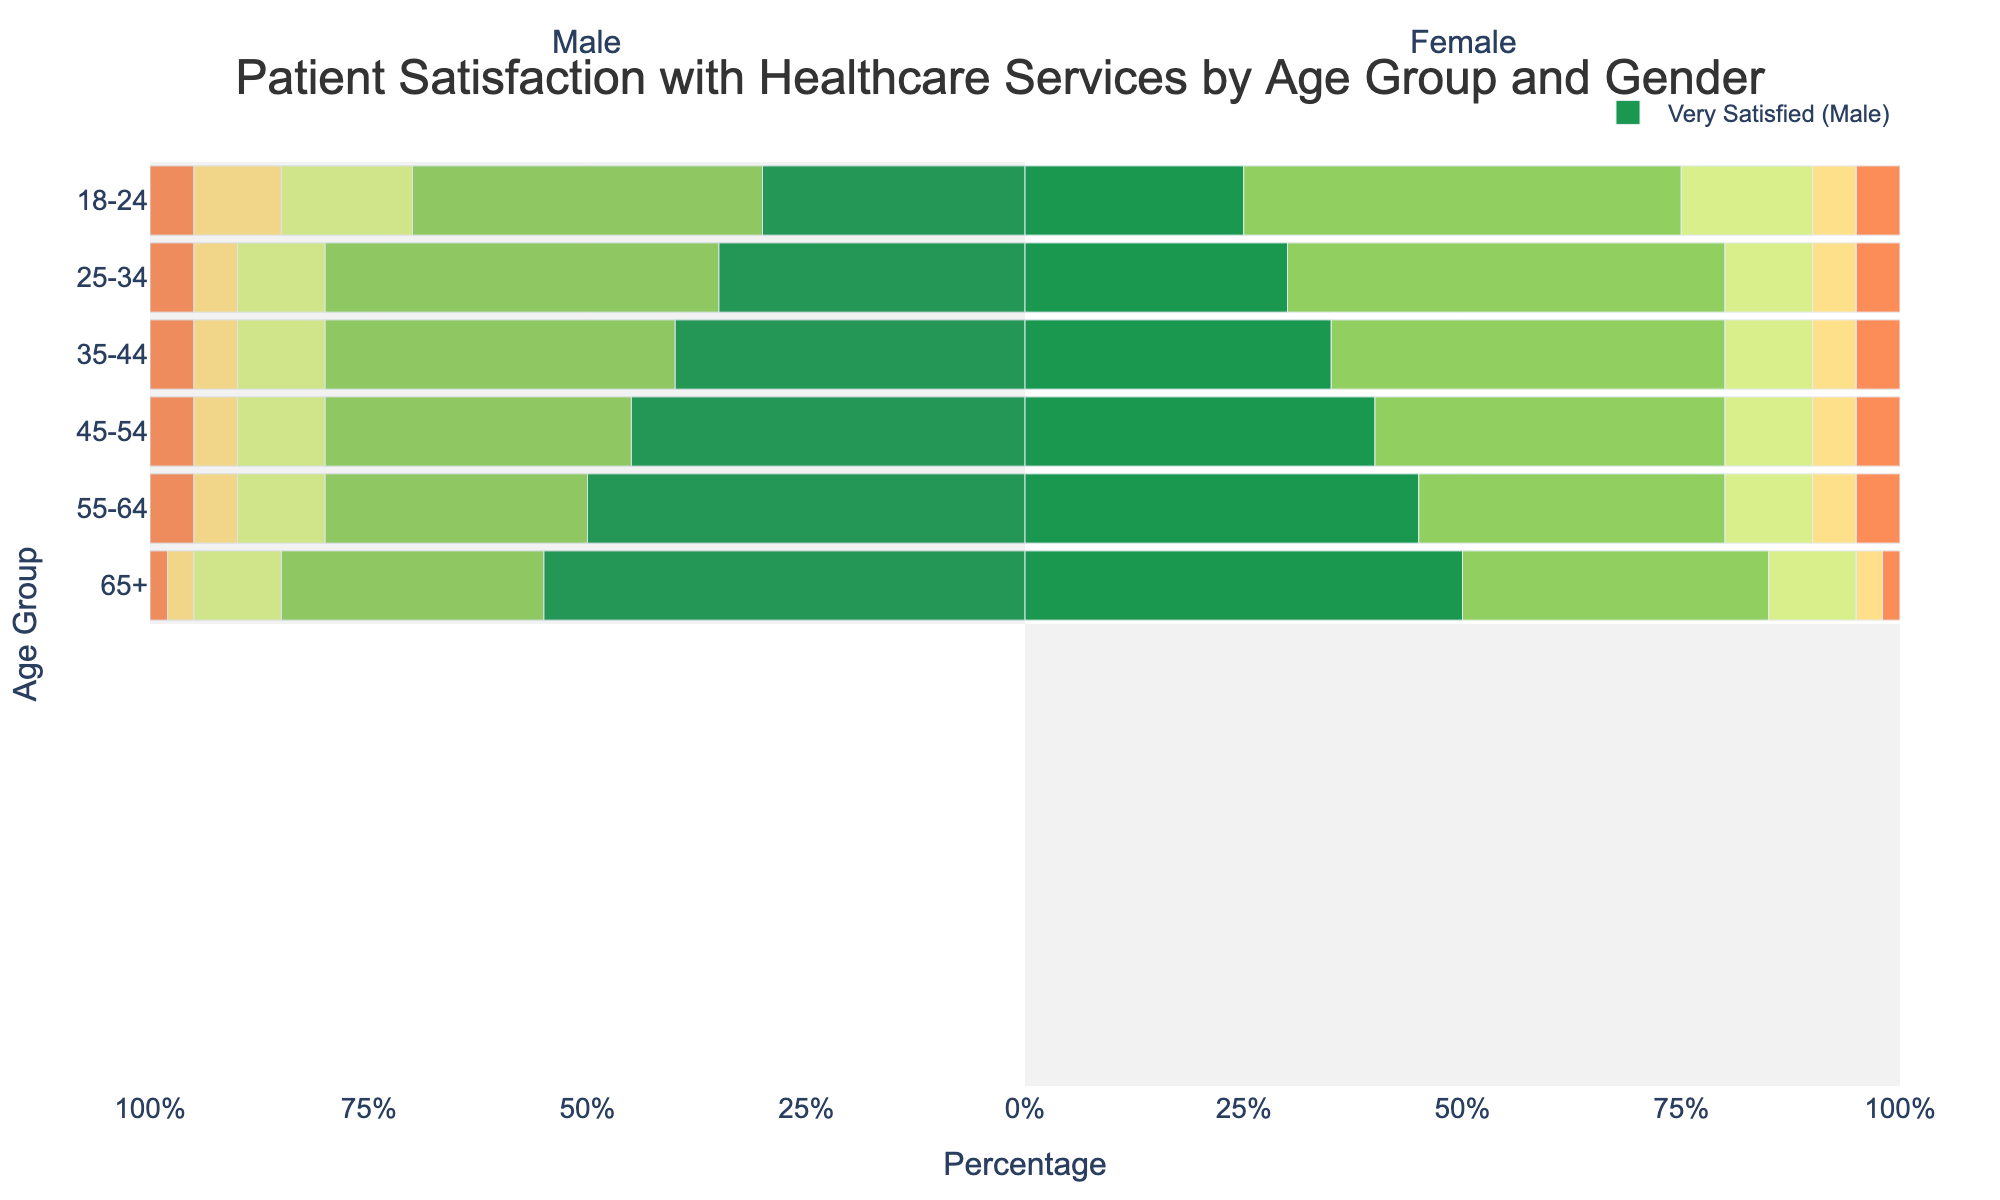What is the total percentage of patients aged 18-24 who are satisfied or very satisfied with healthcare services? To find the total percentage of patients aged 18-24 who are satisfied or very satisfied, sum the percentages of 'Very Satisfied' and 'Satisfied' for both males and females. For males: 30% + 40% = 70%. For females: 25% + 50% = 75%. Since we want the total percentage including both genders, and these are separate groups, we consider both as they are.
Answer: 70% (males), 75% (females) Between males aged 45-54 and females aged 45-54, who has a higher percentage of patients who are very satisfied? Compare the 'Very Satisfied' percentages for males and females in the 45-54 age group. Males: 45%, Females: 40%.
Answer: Males Which age group has the highest percentage of males who are very satisfied? Look for the age group with the highest 'Very Satisfied' percentage among males. 65+ age group has the highest with 55%.
Answer: 65+ For females aged 35-44, what is the combined percentage of those who are neutral or unsatisfied? Add the percentages for 'Neutral' and 'Unsatisfied' for females aged 35-44. Neutral: 10%, Unsatisfied: 5%. Combined: 10% + 5% = 15%.
Answer: 15% What is the difference in the percentage of females who are very unsatisfied between the 55-64 and 65+ age groups? Subtract the percentage of very unsatisfied females in the 65+ age group from that in the 55-64 age group. 55-64: 5%, 65+: 2%. Difference: 5% - 2% = 3%.
Answer: 3% Do males or females have a higher proportion of being very satisfied in the 25-34 age group? Compare the 'Very Satisfied' percentages for males and females in the 25-34 age group. Males: 35%, Females: 30%.
Answer: Males How does the satisfaction level of females aged 55-64 compare to males in the same age group for the categories 'Satisfied' and 'Very Satisfied'? Summing 'Satisfied' and 'Very Satisfied' for each gender, Females: 45% + 35% = 80%, Males: 50% + 30% = 80%. Both have equal satisfaction levels.
Answer: Equal What percentage of females aged 18-24 are either unsatisfied or very unsatisfied? Sum the percentages of 'Unsatisfied' and 'Very Unsatisfied' for females aged 18-24. Unsatisfied: 5%, Very Unsatisfied: 5%. Total: 5% + 5% = 10%.
Answer: 10% Which age group has the lowest combined percentage of males being neutral or unsatisfied? Sum the percentages of 'Neutral' and 'Unsatisfied' for each male age group and find the smallest value. 65+ age group has Neutral: 10%, Unsatisfied: 3%. Combined: 10% + 3% = 13%.
Answer: 65+ What is the ratio of very satisfied males to very satisfied females in the 65+ age group? Find the percentages of 'Very Satisfied' for both genders in the 65+ age group and form the ratio. Males: 55%, Females: 50%. The ratio is 55:50, which simplifies to 11:10.
Answer: 11:10 